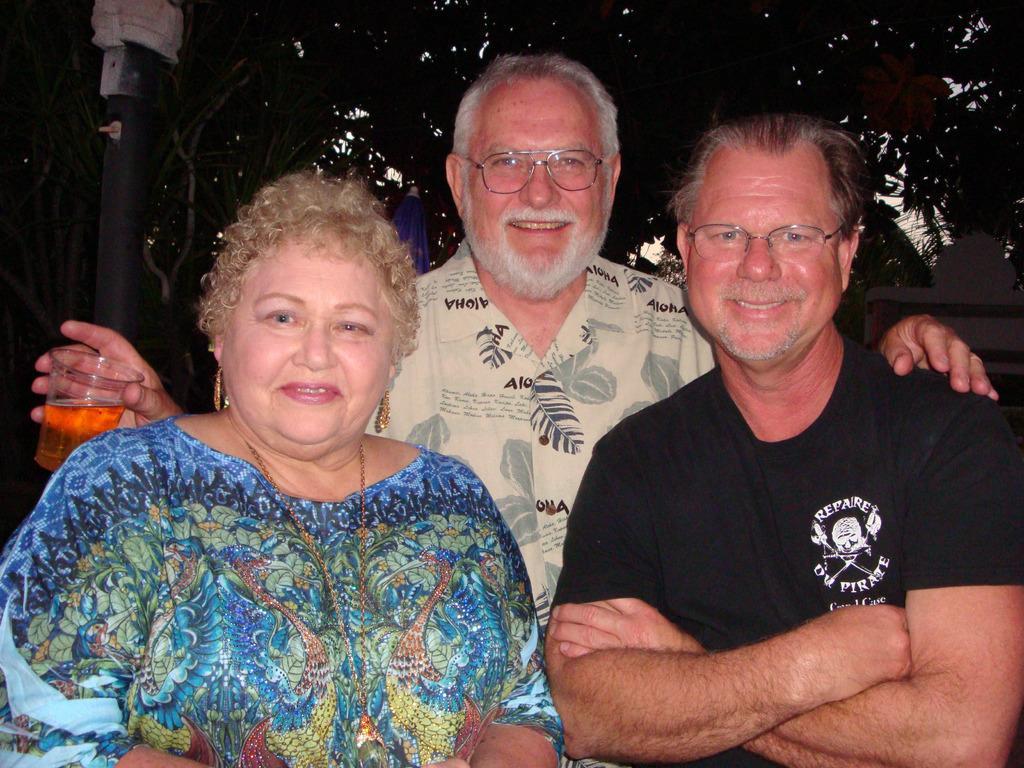In one or two sentences, can you explain what this image depicts? In this image, we can see few peoples are smiling. , few are wearing glasses. At the back side, we can see some plants, rod and board. The middle person is holding a glass, there is a liquid on it. 